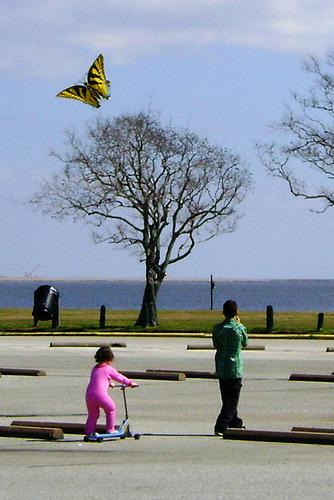The kite here is designed to resemble what? butterfly 